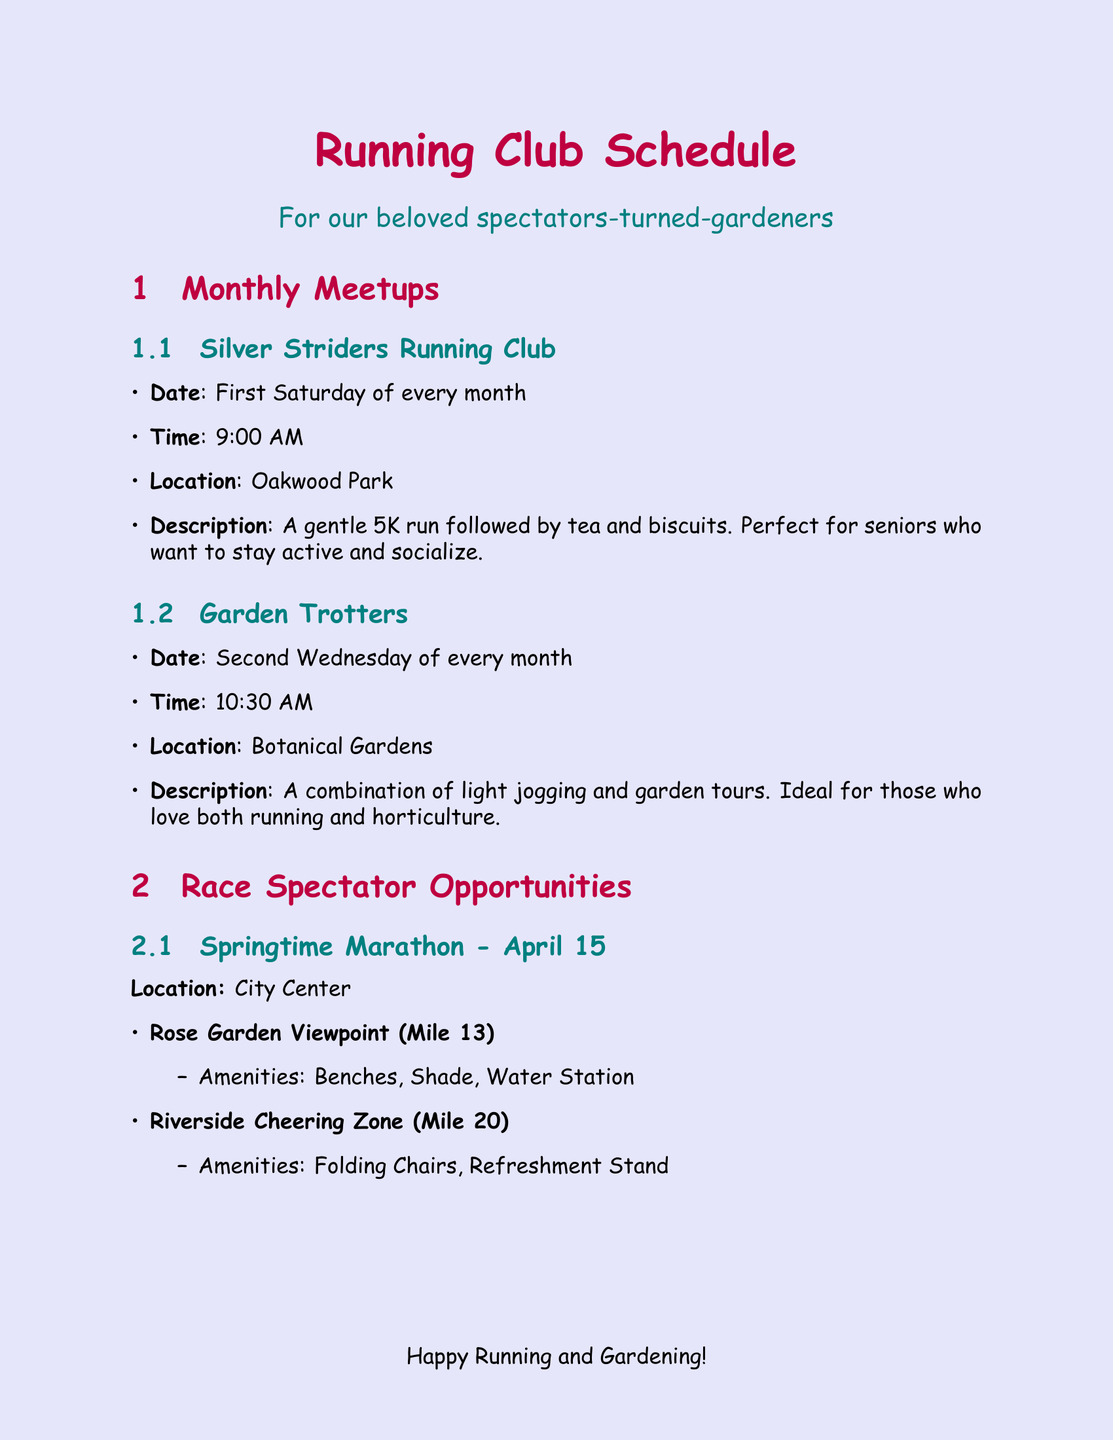What day is the Silver Striders Running Club meeting? The Silver Striders Running Club meets on the first Saturday of every month.
Answer: First Saturday of every month What is the location of the Garden Trotters meetup? The Garden Trotters meetup takes place at the Botanical Gardens.
Answer: Botanical Gardens What is the date of the Springtime Marathon? The Springtime Marathon is scheduled for April 15.
Answer: April 15 Which spectator spot is located at mile marker 3 during the Autumn Leaves 10K? The spectator spot located at mile marker 3 is called Dahlia Dell.
Answer: Dahlia Dell What amenities are available at the Rose Garden Viewpoint? The Rose Garden Viewpoint offers benches, shade, and a water station.
Answer: Benches, Shade, Water Station What is the purpose of the Runners' Garden Party? The Runners' Garden Party is a gathering for runners and former spectators to share stories and gardening tips.
Answer: Sharing stories and gardening tips Which social event encourages attendees to bring a plant? The Runners' Garden Party encourages attendees to bring a plant to swap.
Answer: Runners' Garden Party What role does a "Finish Line Gardener" play? A Finish Line Gardener helps maintain and beautify the landscaping around race finish lines.
Answer: Maintain and beautify landscaping How often do the monthly meetups occur? The monthly meetups are held every month.
Answer: Every month What is the date and time for the Race Photo Reminiscence Night? The Race Photo Reminiscence Night occurs on November 12 at 6:30 PM.
Answer: November 12, 6:30 PM 